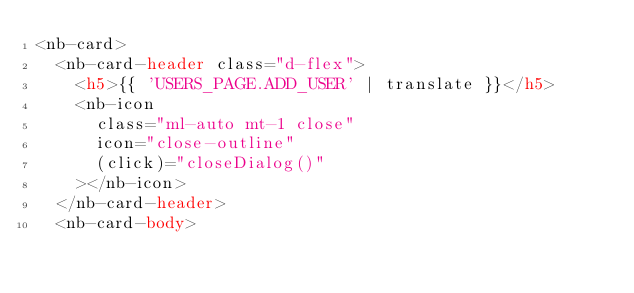Convert code to text. <code><loc_0><loc_0><loc_500><loc_500><_HTML_><nb-card>
	<nb-card-header class="d-flex">
		<h5>{{ 'USERS_PAGE.ADD_USER' | translate }}</h5>
		<nb-icon
			class="ml-auto mt-1 close"
			icon="close-outline"
			(click)="closeDialog()"
		></nb-icon>
	</nb-card-header>
	<nb-card-body></code> 